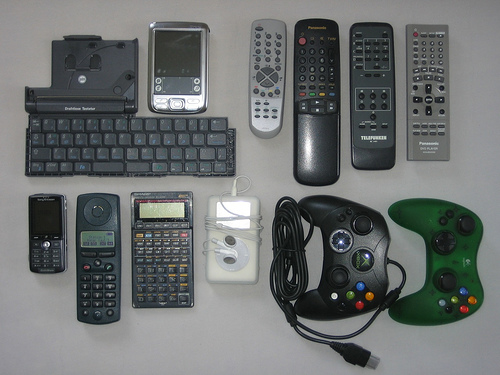<image>Which two remotes are the same brand? I am not sure which two remotes are the same brand. They could be the xbox remotes or perhaps two others. Which two remotes are the same brand? I don't know which two remotes are the same brand. It can be seen 'xbox', 'bottom left two', 'bottom right two' or 'xbox remotes'. 